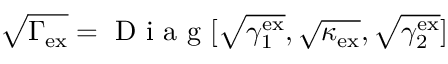<formula> <loc_0><loc_0><loc_500><loc_500>\sqrt { \Gamma _ { e x } } = D i a g [ \sqrt { \gamma _ { 1 } ^ { e x } } , \sqrt { \kappa _ { e x } } , \sqrt { \gamma _ { 2 } ^ { e x } } ]</formula> 